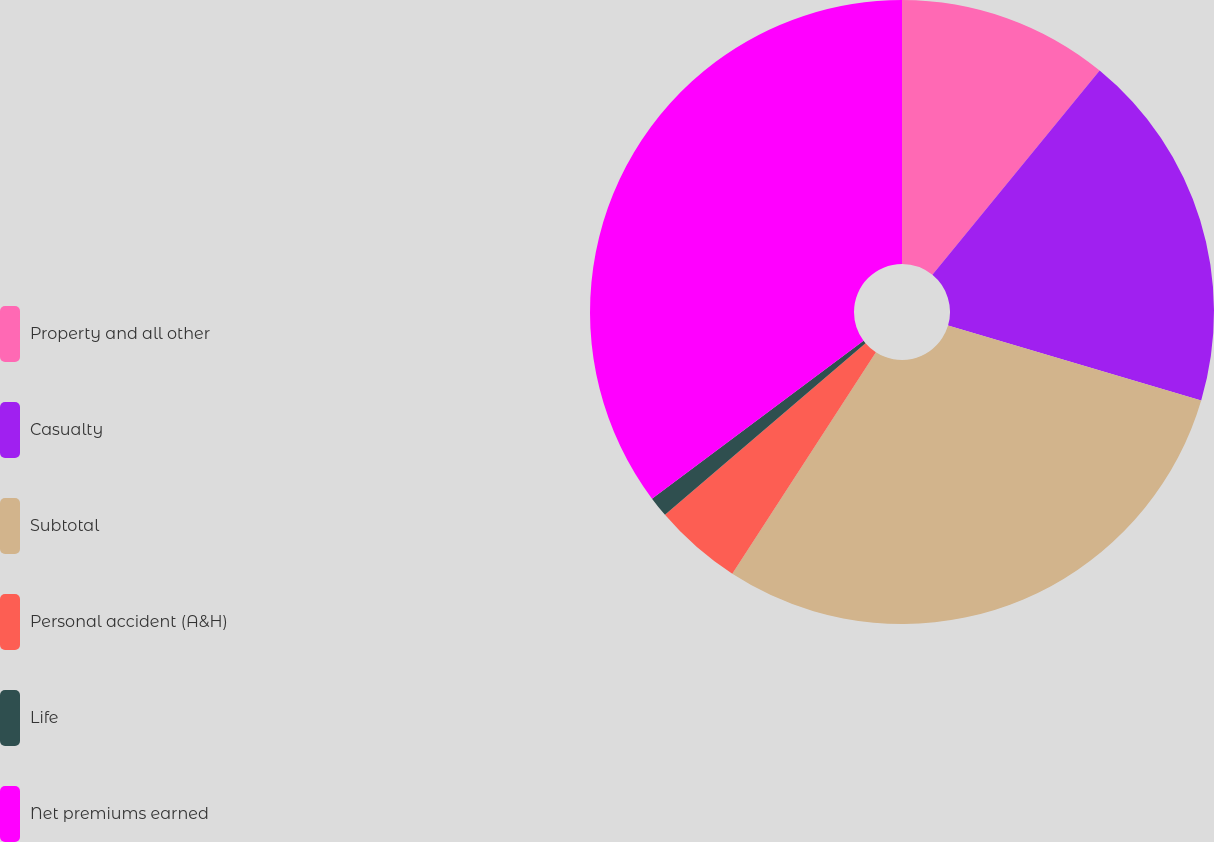Convert chart. <chart><loc_0><loc_0><loc_500><loc_500><pie_chart><fcel>Property and all other<fcel>Casualty<fcel>Subtotal<fcel>Personal accident (A&H)<fcel>Life<fcel>Net premiums earned<nl><fcel>10.92%<fcel>18.66%<fcel>29.58%<fcel>4.58%<fcel>1.06%<fcel>35.21%<nl></chart> 